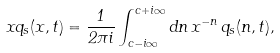<formula> <loc_0><loc_0><loc_500><loc_500>x q _ { s } ( x , t ) = \frac { 1 } { 2 \pi i } \int _ { c - i \infty } ^ { c + i \infty } d n \, x ^ { - n } \, q _ { s } ( n , t ) ,</formula> 